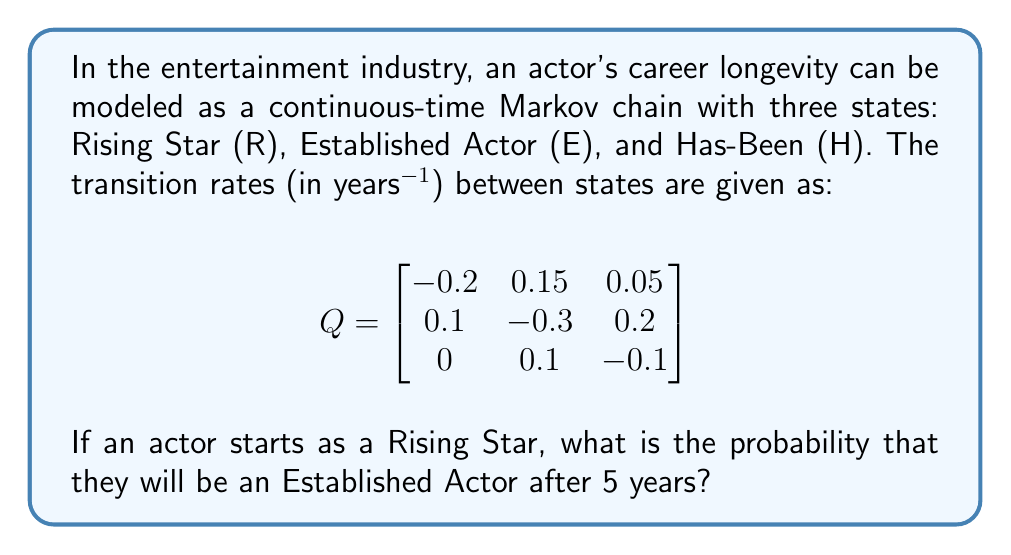Can you answer this question? To solve this problem, we need to use the continuous-time Markov chain transition probability formula:

$$P(t) = e^{Qt}$$

Where $P(t)$ is the transition probability matrix at time $t$, $Q$ is the given transition rate matrix, and $e$ is the matrix exponential.

Steps to solve:

1) First, we need to calculate $Qt$:

   $$Qt = \begin{bmatrix}
   -1 & 0.75 & 0.25 \\
   0.5 & -1.5 & 1 \\
   0 & 0.5 & -0.5
   \end{bmatrix}$$

2) Next, we need to calculate $e^{Qt}$. This is typically done using numerical methods or software. Using a mathematical software, we get:

   $$e^{Qt} = \begin{bmatrix}
   0.4066 & 0.4410 & 0.1524 \\
   0.2940 & 0.4885 & 0.2175 \\
   0.1470 & 0.4918 & 0.3612
   \end{bmatrix}$$

3) The probability we're looking for is the entry in the first row (Rising Star) and second column (Established Actor) of this matrix.

Therefore, the probability that an actor who starts as a Rising Star will be an Established Actor after 5 years is approximately 0.4410 or 44.10%.
Answer: 0.4410 